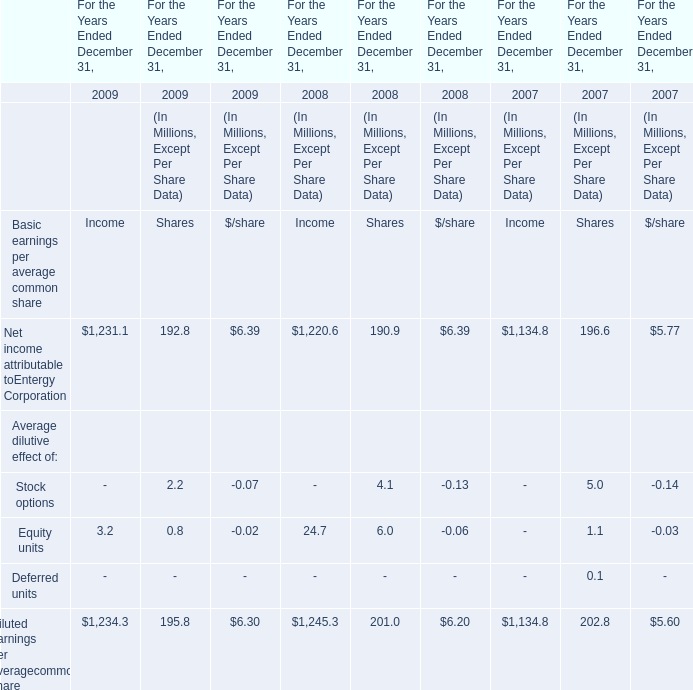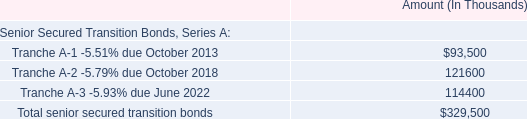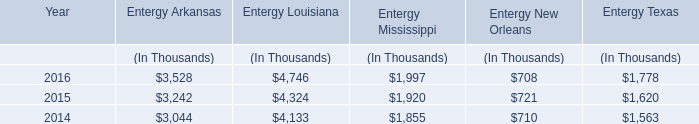relating to the texas securitization bonds , what were the total amounts ( millions ) of the issuance when considering the transaction costs and the related deferred income tax benefits? 
Computations: ((353 + 6) - 32)
Answer: 327.0. 